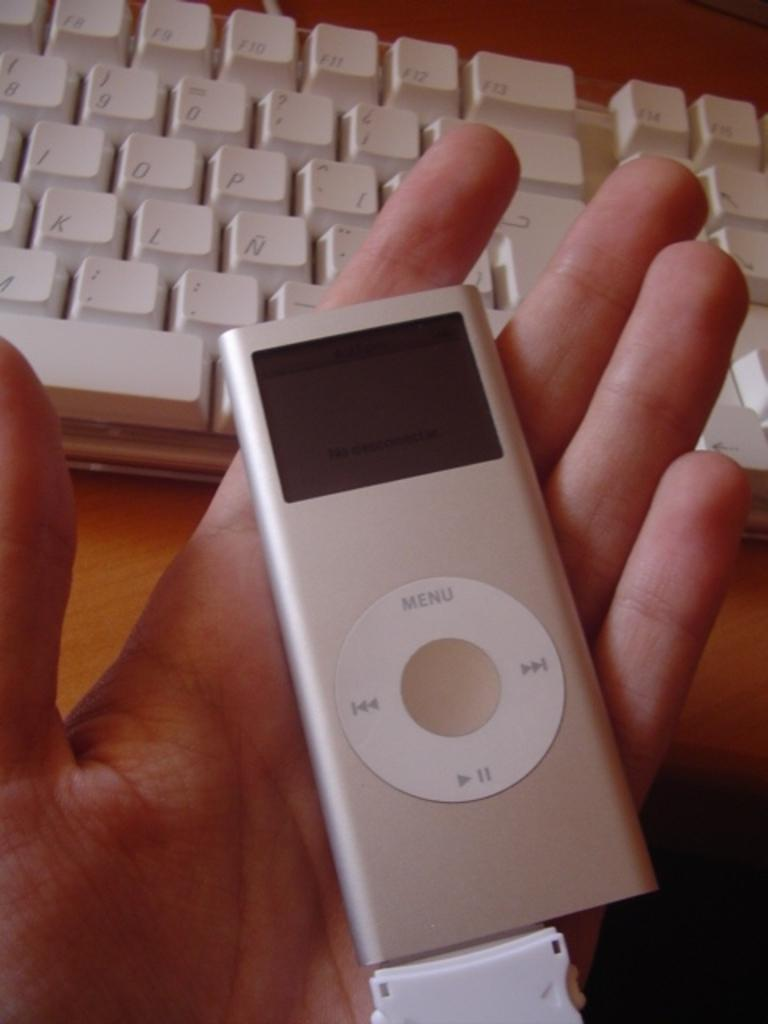What is the person's hand holding in the image? There is a device being held by a person's hand in the image. What is the device connected to in the image? The device is connected to a keyboard in the image. What is the surface made of that the keyboard is placed on? The keyboard is placed on a wooden surface in the image. How many brains can be seen on the shelf in the image? There is no shelf or brain present in the image. What type of chairs are visible in the image? There are no chairs visible in the image. 